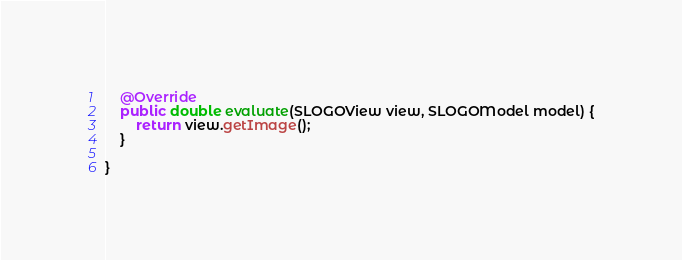<code> <loc_0><loc_0><loc_500><loc_500><_Java_>
	@Override
	public double evaluate(SLOGOView view, SLOGOModel model) {
		return view.getImage();
	}

}
</code> 